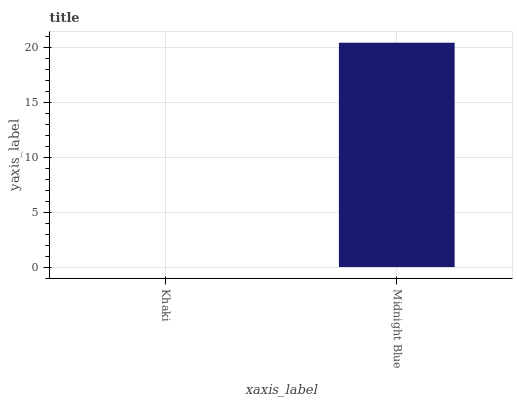Is Khaki the minimum?
Answer yes or no. Yes. Is Midnight Blue the maximum?
Answer yes or no. Yes. Is Midnight Blue the minimum?
Answer yes or no. No. Is Midnight Blue greater than Khaki?
Answer yes or no. Yes. Is Khaki less than Midnight Blue?
Answer yes or no. Yes. Is Khaki greater than Midnight Blue?
Answer yes or no. No. Is Midnight Blue less than Khaki?
Answer yes or no. No. Is Midnight Blue the high median?
Answer yes or no. Yes. Is Khaki the low median?
Answer yes or no. Yes. Is Khaki the high median?
Answer yes or no. No. Is Midnight Blue the low median?
Answer yes or no. No. 